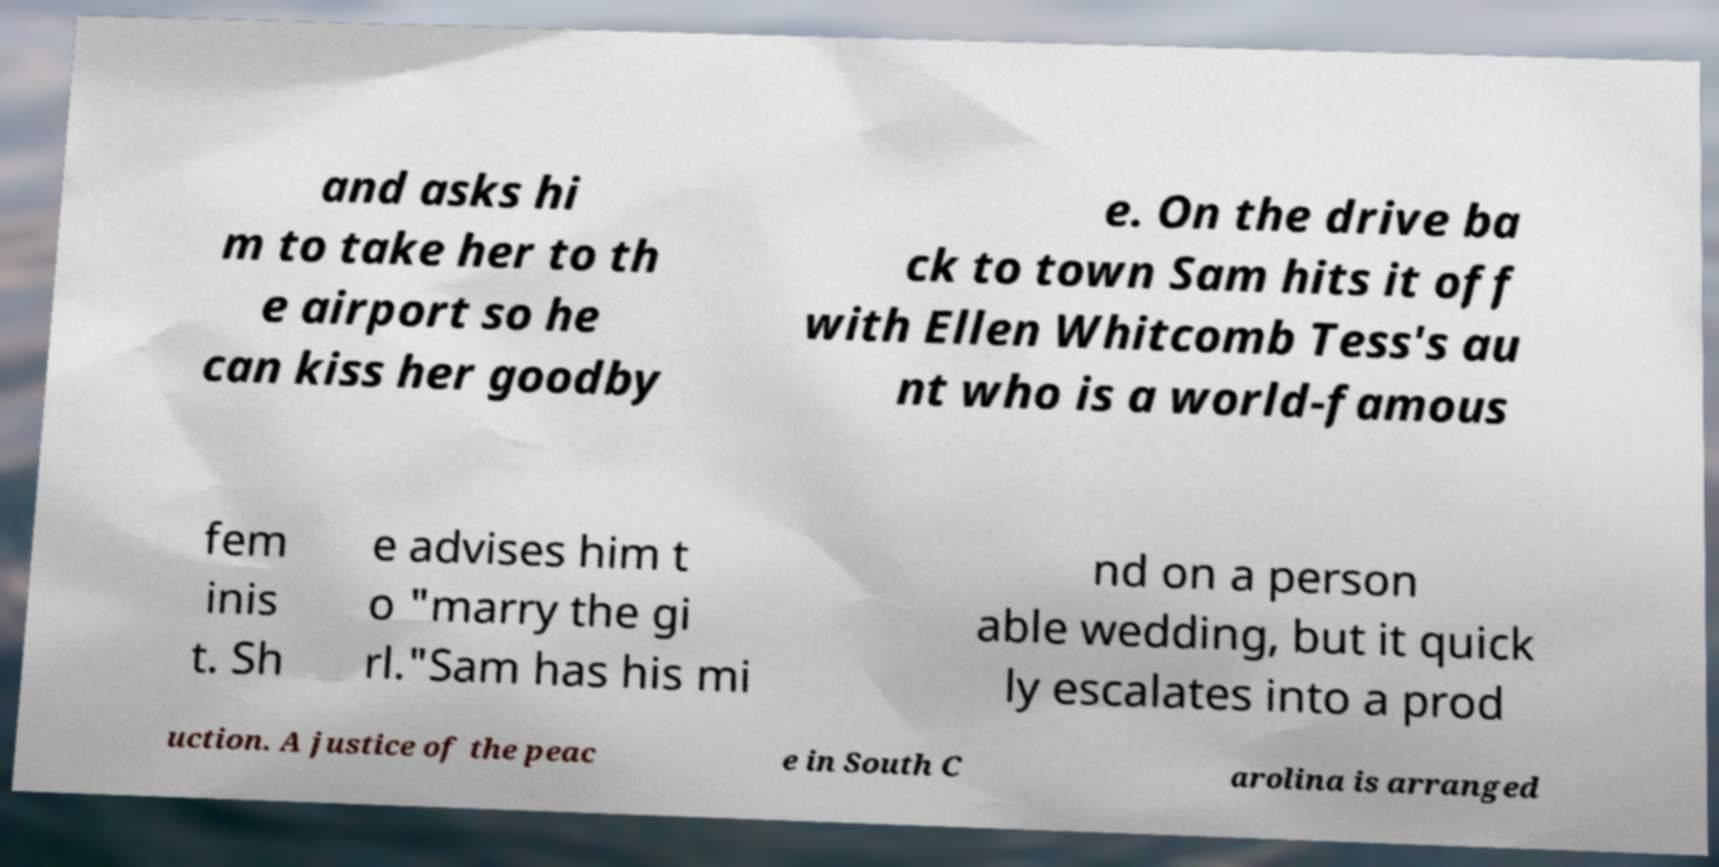Please read and relay the text visible in this image. What does it say? and asks hi m to take her to th e airport so he can kiss her goodby e. On the drive ba ck to town Sam hits it off with Ellen Whitcomb Tess's au nt who is a world-famous fem inis t. Sh e advises him t o "marry the gi rl."Sam has his mi nd on a person able wedding, but it quick ly escalates into a prod uction. A justice of the peac e in South C arolina is arranged 